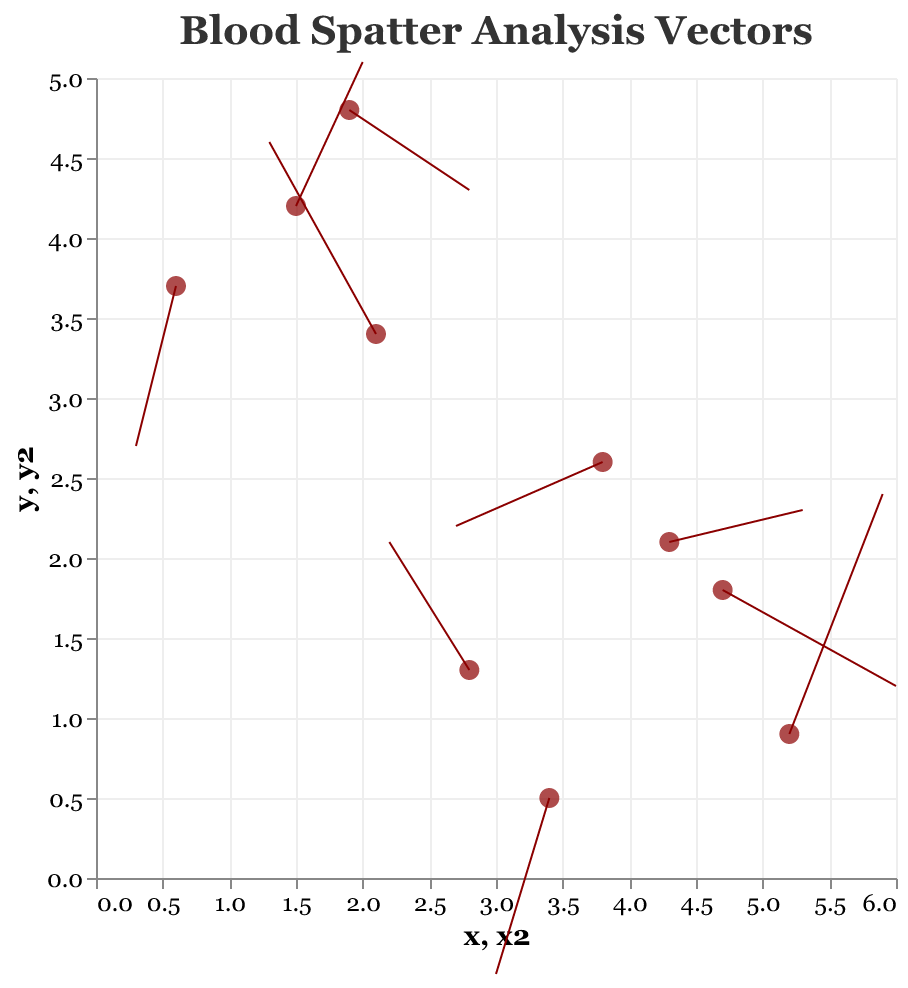How many data points are plotted in the quiver plot? There are 10 different sets of coordinates, each representing a data point in the figure.
Answer: 10 What is the title of the quiver plot? The title is displayed at the top of the figure. It reads "Blood Spatter Analysis Vectors."
Answer: Blood Spatter Analysis Vectors What is the color of the points representing the origin of each vector? The points are filled and their color is specified as a dark red. This is visible in the figure.
Answer: Dark red Which vector has the highest magnitude? The magnitude values are provided within the dataset. The highest value is 1.7, corresponding to the vector originating at (5.2, 0.9).
Answer: The vector at (5.2, 0.9) What are the coordinates and direction components for the vector with the lowest magnitude? The lowest magnitude is 1.0. There are several vectors with this magnitude, such as (1.5, 4.2) with direction components (0.5, 0.9) and (4.3, 2.1) with direction components (1.0, 0.2).
Answer: (1.5, 4.2) and (4.3, 2.1) and (2.8, 1.3) and (1.9, 4.8) How many vectors point in a mostly upward direction? Vectors that point mostly upwards have a positive 'v' component. Checking the dataset, these vectors are at (2.1, 3.4), (1.5, 4.2), (5.2, 0.9), and (2.8, 1.3).
Answer: 4 Is there any vector that points almost horizontally? A vector pointing almost horizontally would have a 'v' component close to zero. The vector at (4.3, 2.1) with components (1.0, 0.2) fits this description.
Answer: Yes Which vector has the most negative x-direction component? The most negative 'u' component is -1.1, which corresponds to the vector at (3.8, 2.6).
Answer: The vector at (3.8, 2.6) What is the average magnitude of all the vectors? Sum the magnitudes (1.5 + 1.4 + 1.0 + 1.2 + 1.7 + 1.1 + 1.0 + 1.0 + 1.0 + 1.2) and divide by the number of vectors (10). Thus, (13.1 / 10) = 1.31.
Answer: 1.31 Is there a vector that points down and to the left? A vector pointing down and to the left would have both a negative 'u' and a negative 'v'. The dataset shows that the vector at (0.6, 3.7) with components (-0.3, -1.0) fits this criterion.
Answer: Yes 